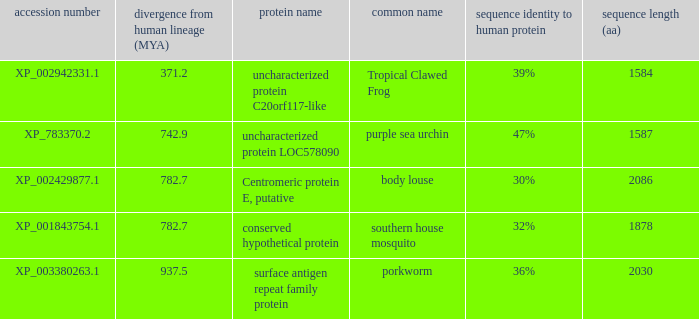What is the accession number of the protein with a divergence from human lineage of 937.5? XP_003380263.1. 